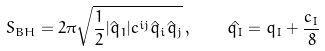<formula> <loc_0><loc_0><loc_500><loc_500>S _ { B H } = 2 \pi \sqrt { \frac { 1 } { 2 } | \hat { q } _ { 1 } | c ^ { i j } \hat { q } _ { i } \hat { q } _ { j } } \, , \quad \hat { q _ { I } } = q _ { I } + \frac { c _ { I } } { 8 }</formula> 